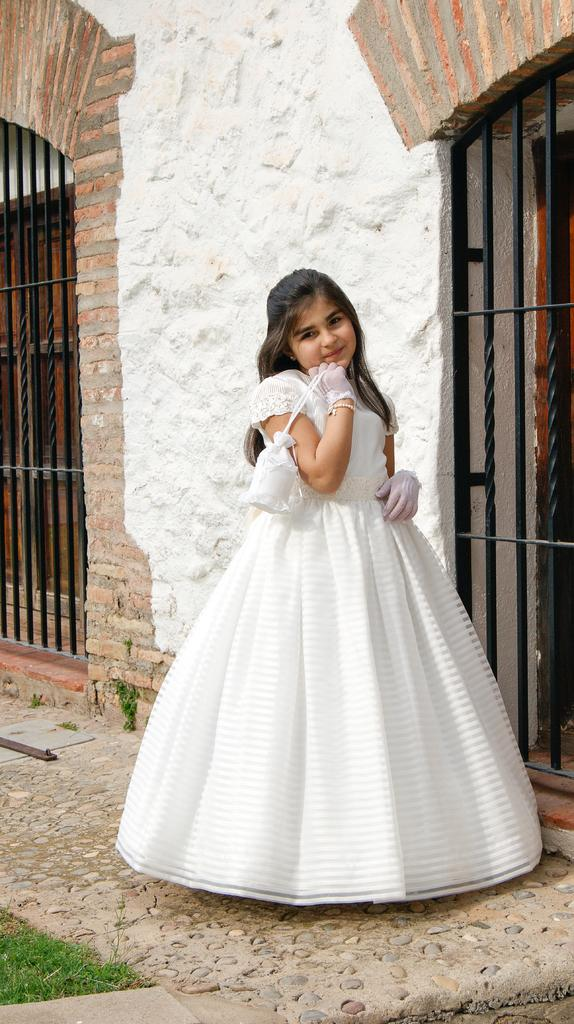Who is the main subject in the image? There is a girl in the image. What is the girl doing in the image? The girl is standing in the image. What is the girl holding in her hand? The girl is holding a small bag in her hand. What can be seen in the background of the image? There are gates, a wall, and doors in the background of the image. What type of ground is visible in the image? Grass is present on the ground in the image. What time does the team arrive in the image? There is no team present in the image, and therefore no arrival time can be determined. How many bites has the girl taken out of the small bag in the image? The girl is holding a small bag, not something to be bitten, so there is no indication of bites taken. 